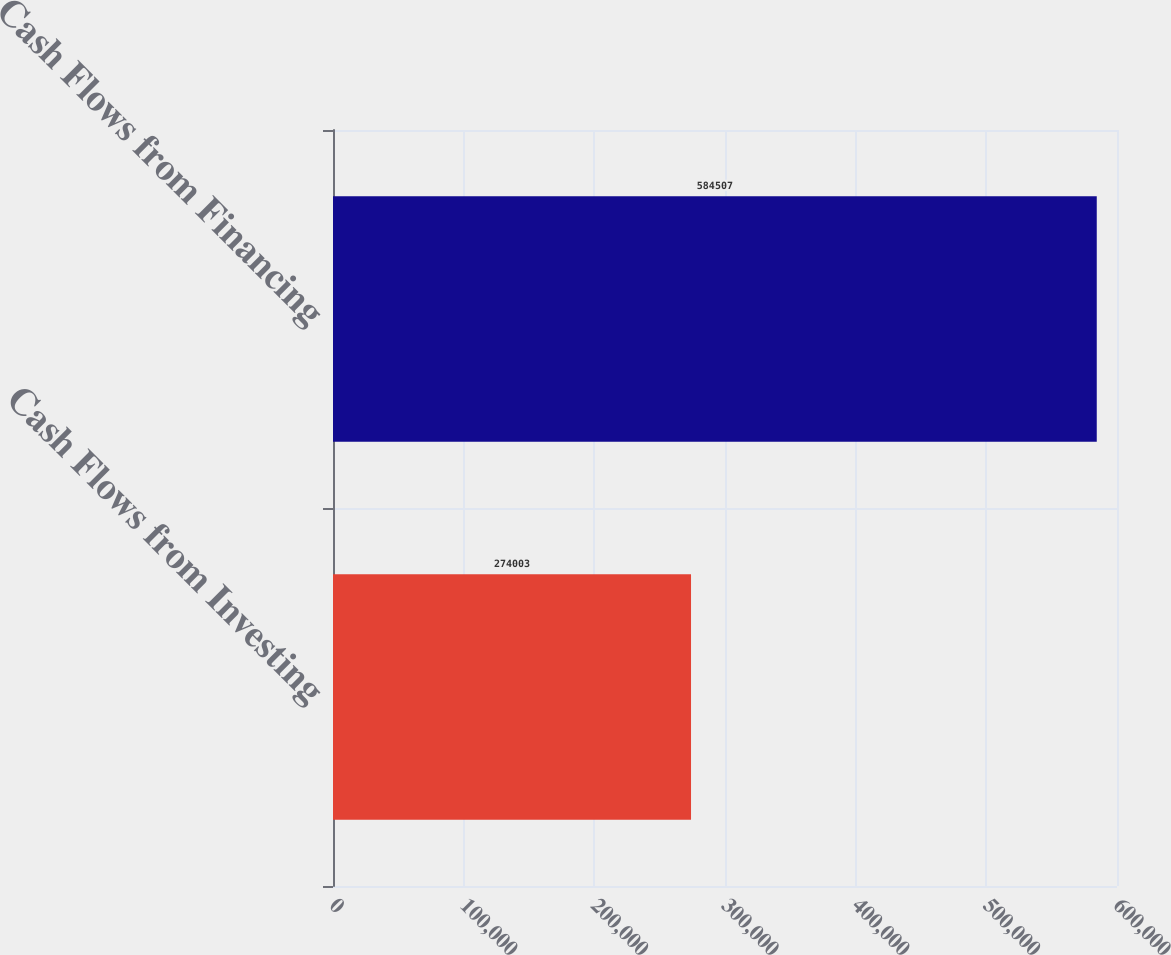Convert chart to OTSL. <chart><loc_0><loc_0><loc_500><loc_500><bar_chart><fcel>Cash Flows from Investing<fcel>Cash Flows from Financing<nl><fcel>274003<fcel>584507<nl></chart> 